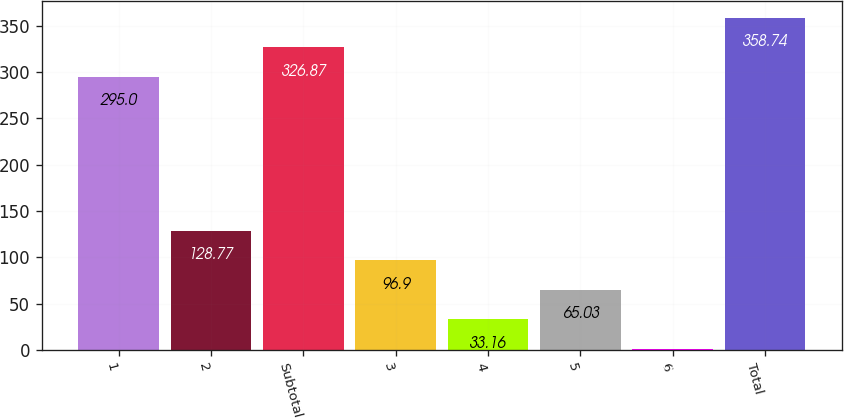<chart> <loc_0><loc_0><loc_500><loc_500><bar_chart><fcel>1<fcel>2<fcel>Subtotal<fcel>3<fcel>4<fcel>5<fcel>6<fcel>Total<nl><fcel>295<fcel>128.77<fcel>326.87<fcel>96.9<fcel>33.16<fcel>65.03<fcel>1.29<fcel>358.74<nl></chart> 